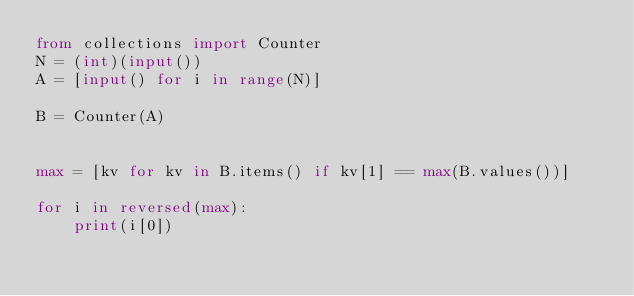Convert code to text. <code><loc_0><loc_0><loc_500><loc_500><_Python_>from collections import Counter
N = (int)(input())
A = [input() for i in range(N)]

B = Counter(A)


max = [kv for kv in B.items() if kv[1] == max(B.values())]

for i in reversed(max):
    print(i[0])</code> 